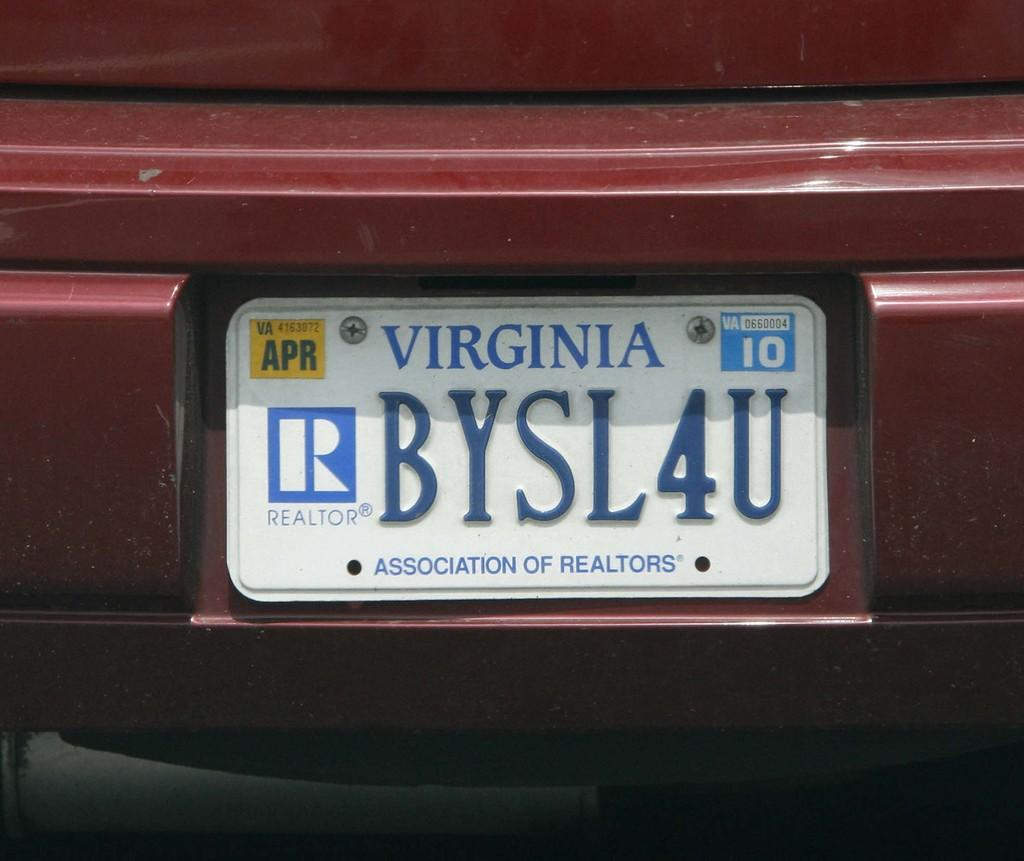<image>
Relay a brief, clear account of the picture shown. A closeup of a Virginia license plate BYSL4U with an Association of Realtors designation on it. 